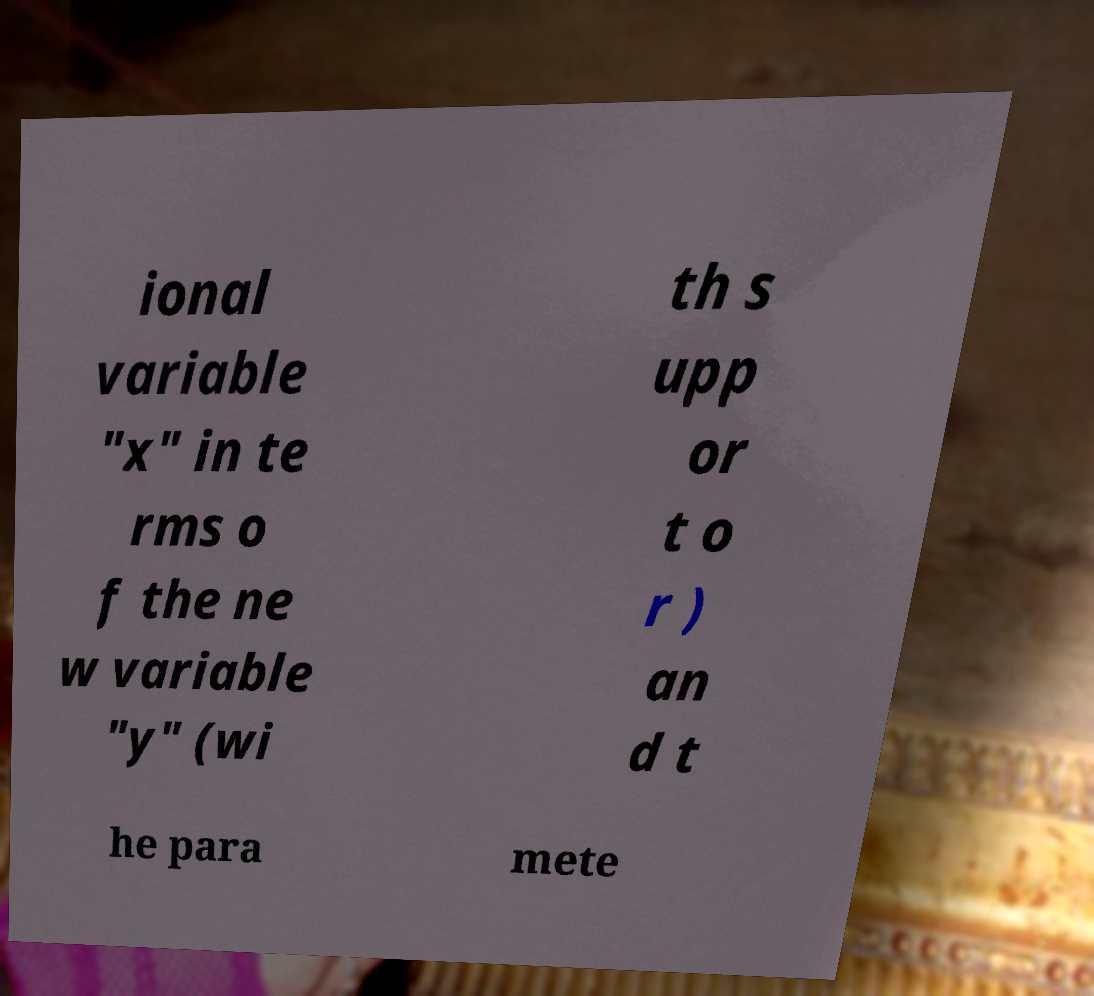Could you assist in decoding the text presented in this image and type it out clearly? ional variable "x" in te rms o f the ne w variable "y" (wi th s upp or t o r ) an d t he para mete 